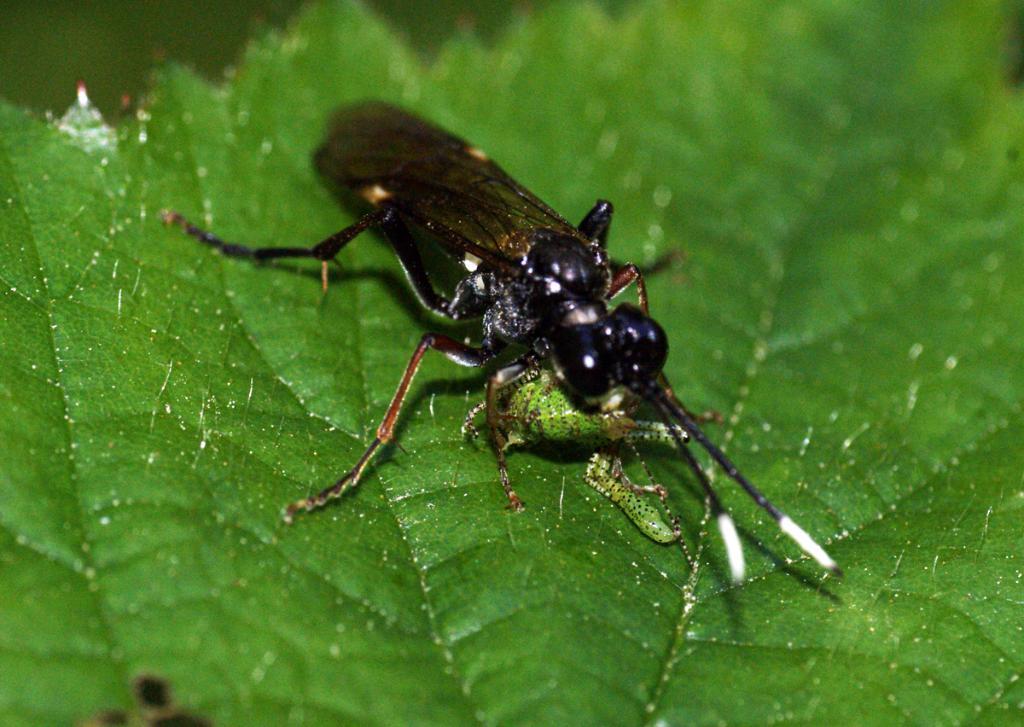How would you summarize this image in a sentence or two? In this picture we can see an insect in the front, at the bottom there is a leaf, we can see a blurry background. 